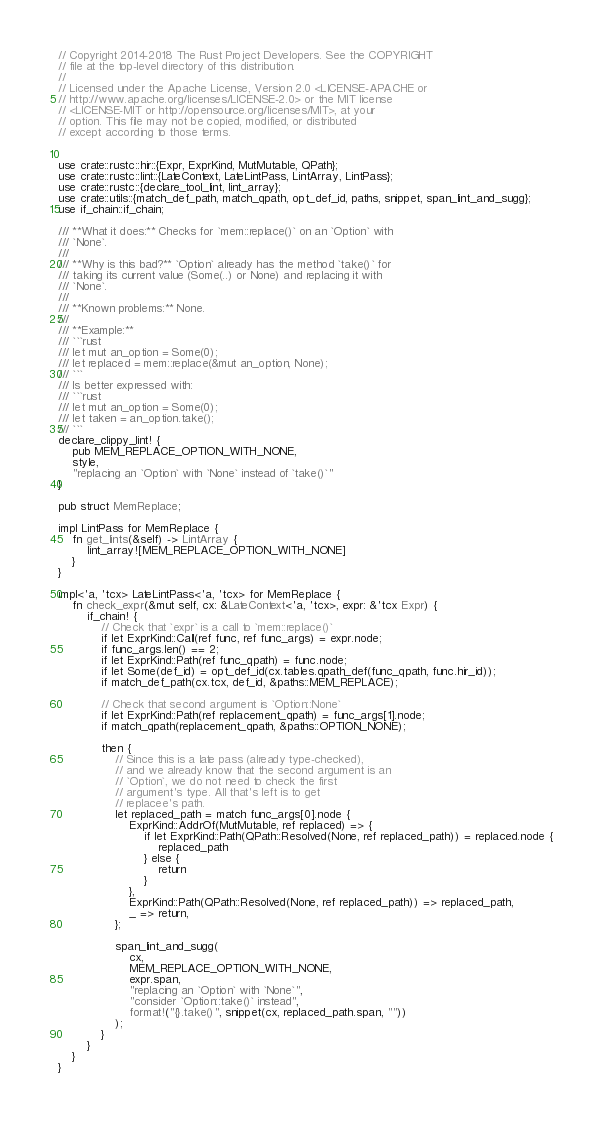Convert code to text. <code><loc_0><loc_0><loc_500><loc_500><_Rust_>// Copyright 2014-2018 The Rust Project Developers. See the COPYRIGHT
// file at the top-level directory of this distribution.
//
// Licensed under the Apache License, Version 2.0 <LICENSE-APACHE or
// http://www.apache.org/licenses/LICENSE-2.0> or the MIT license
// <LICENSE-MIT or http://opensource.org/licenses/MIT>, at your
// option. This file may not be copied, modified, or distributed
// except according to those terms.


use crate::rustc::hir::{Expr, ExprKind, MutMutable, QPath};
use crate::rustc::lint::{LateContext, LateLintPass, LintArray, LintPass};
use crate::rustc::{declare_tool_lint, lint_array};
use crate::utils::{match_def_path, match_qpath, opt_def_id, paths, snippet, span_lint_and_sugg};
use if_chain::if_chain;

/// **What it does:** Checks for `mem::replace()` on an `Option` with
/// `None`.
///
/// **Why is this bad?** `Option` already has the method `take()` for
/// taking its current value (Some(..) or None) and replacing it with
/// `None`.
///
/// **Known problems:** None.
///
/// **Example:**
/// ```rust
/// let mut an_option = Some(0);
/// let replaced = mem::replace(&mut an_option, None);
/// ```
/// Is better expressed with:
/// ```rust
/// let mut an_option = Some(0);
/// let taken = an_option.take();
/// ```
declare_clippy_lint! {
    pub MEM_REPLACE_OPTION_WITH_NONE,
    style,
    "replacing an `Option` with `None` instead of `take()`"
}

pub struct MemReplace;

impl LintPass for MemReplace {
    fn get_lints(&self) -> LintArray {
        lint_array![MEM_REPLACE_OPTION_WITH_NONE]
    }
}

impl<'a, 'tcx> LateLintPass<'a, 'tcx> for MemReplace {
    fn check_expr(&mut self, cx: &LateContext<'a, 'tcx>, expr: &'tcx Expr) {
        if_chain! {
            // Check that `expr` is a call to `mem::replace()`
            if let ExprKind::Call(ref func, ref func_args) = expr.node;
            if func_args.len() == 2;
            if let ExprKind::Path(ref func_qpath) = func.node;
            if let Some(def_id) = opt_def_id(cx.tables.qpath_def(func_qpath, func.hir_id));
            if match_def_path(cx.tcx, def_id, &paths::MEM_REPLACE);

            // Check that second argument is `Option::None`
            if let ExprKind::Path(ref replacement_qpath) = func_args[1].node;
            if match_qpath(replacement_qpath, &paths::OPTION_NONE);

            then {
                // Since this is a late pass (already type-checked),
                // and we already know that the second argument is an
                // `Option`, we do not need to check the first
                // argument's type. All that's left is to get
                // replacee's path.
                let replaced_path = match func_args[0].node {
                    ExprKind::AddrOf(MutMutable, ref replaced) => {
                        if let ExprKind::Path(QPath::Resolved(None, ref replaced_path)) = replaced.node {
                            replaced_path
                        } else {
                            return
                        }
                    },
                    ExprKind::Path(QPath::Resolved(None, ref replaced_path)) => replaced_path,
                    _ => return,
                };

                span_lint_and_sugg(
                    cx,
                    MEM_REPLACE_OPTION_WITH_NONE,
                    expr.span,
                    "replacing an `Option` with `None`",
                    "consider `Option::take()` instead",
                    format!("{}.take()", snippet(cx, replaced_path.span, ""))
                );
            }
        }
    }
}
</code> 